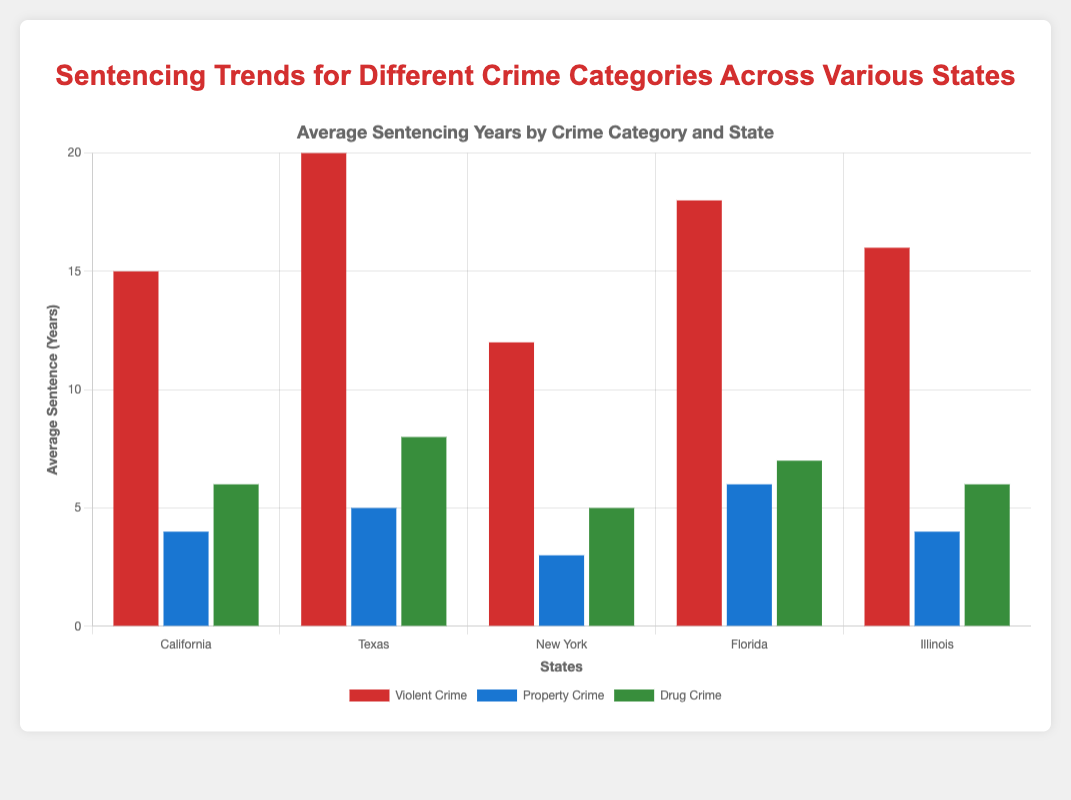Which state has the longest average sentence for violent crimes, and what is that sentence? California, Texas, New York, Florida, and Illinois are compared for violent crimes. Texas has the longest average sentence for violent crimes at 20 years.
Answer: Texas, 20 years Which state has the shortest average sentence for property crimes, and what is that sentence? California, Texas, New York, Florida, and Illinois are compared for property crimes. New York has the shortest average sentence for property crimes at 3 years.
Answer: New York, 3 years Which crime category in Florida has the highest average sentence, and what is that sentence? Florida's violent crime, property crime, and drug crime sentences are compared. Violent crimes have the highest average sentence at 18 years.
Answer: Violent Crime, 18 years By how many years does Texas' average sentence for drug crimes exceed California's? The average sentence for drug crimes in Texas is 8 years, while in California, it is 6 years. The difference is 8 - 6 = 2 years.
Answer: 2 years Which state has the most balanced average sentences among the three crime categories? By comparing the average sentences among the three crime categories for California, Texas, New York, Florida, and Illinois, it is evident Illinois has similar sentences (16 years for violent, 4 years for property, and 6 years for drug crimes).
Answer: Illinois What are the average sentences for violent crimes in all states combined? Summing up the average sentences for violent crimes in California (15), Texas (20), New York (12), Florida (18), and Illinois (16) and averaging them: (15 + 20 + 12 + 18 + 16) / 5 = 16.2 years.
Answer: 16.2 years Which state has a higher average sentence for drug crimes, Illinois or New York, and by how many years? Illinois has an average sentence of 6 years for drug crimes, while New York has an average of 5 years. The difference is 6 - 5 = 1 year, so Illinois has a higher sentence by 1 year.
Answer: Illinois, 1 year Which crime category in Texas has the lowest average sentence, and what is that sentence? Comparing Texas' violent crime (20 years), property crime (5 years), and drug crime (8 years), property crimes have the lowest average sentence at 5 years.
Answer: Property Crime, 5 years 